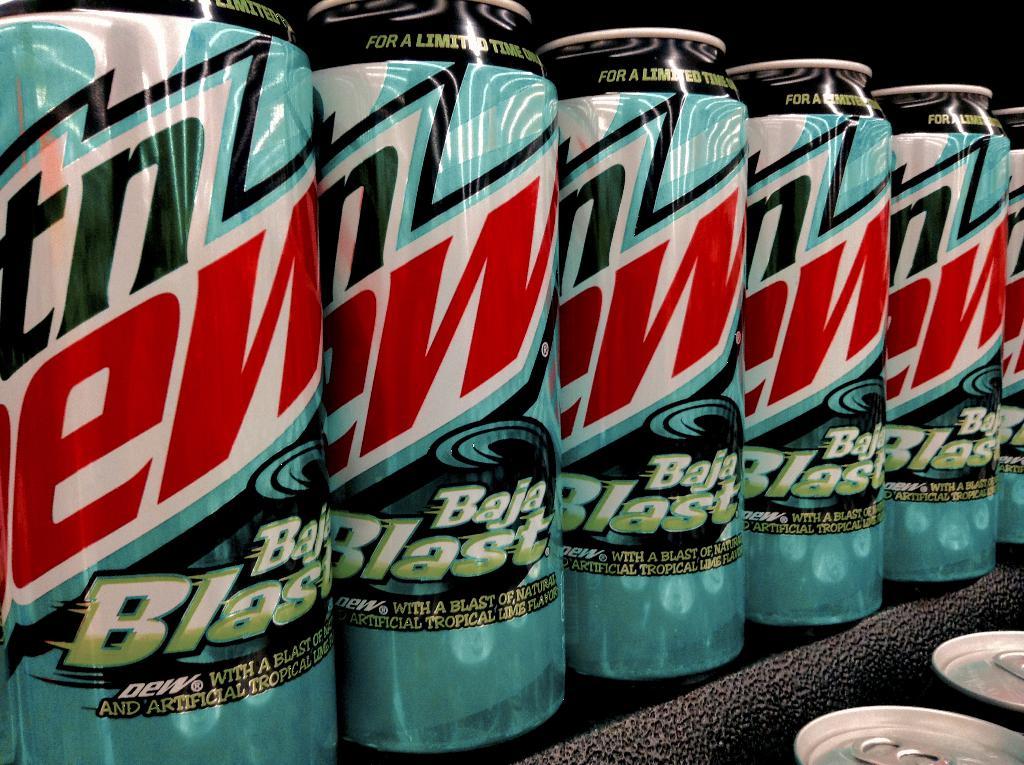What brand are these drinks from?
Your response must be concise. Mtn dew. What flavor is it?
Ensure brevity in your answer.  Baja blast. 